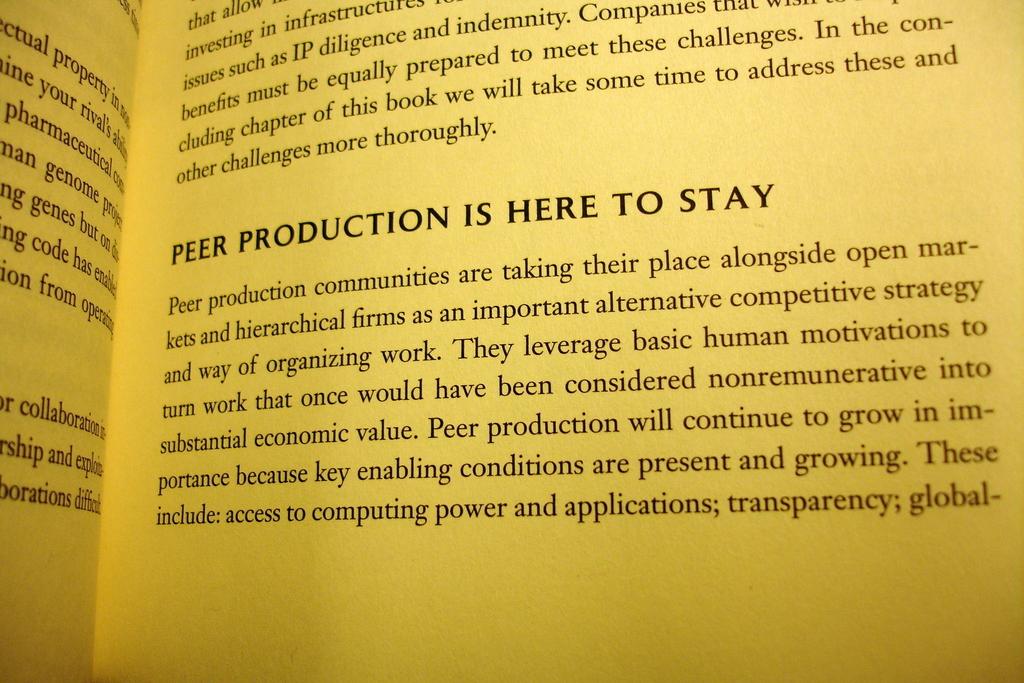What is the last word of the sentence on the top paragraph?
Offer a very short reply. Thoroughly. 